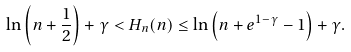Convert formula to latex. <formula><loc_0><loc_0><loc_500><loc_500>\ln \left ( n + \frac { 1 } { 2 } \right ) + \gamma < H _ { n } ( n ) \leq \ln \left ( n + e ^ { 1 - \gamma } - 1 \right ) + \gamma .</formula> 